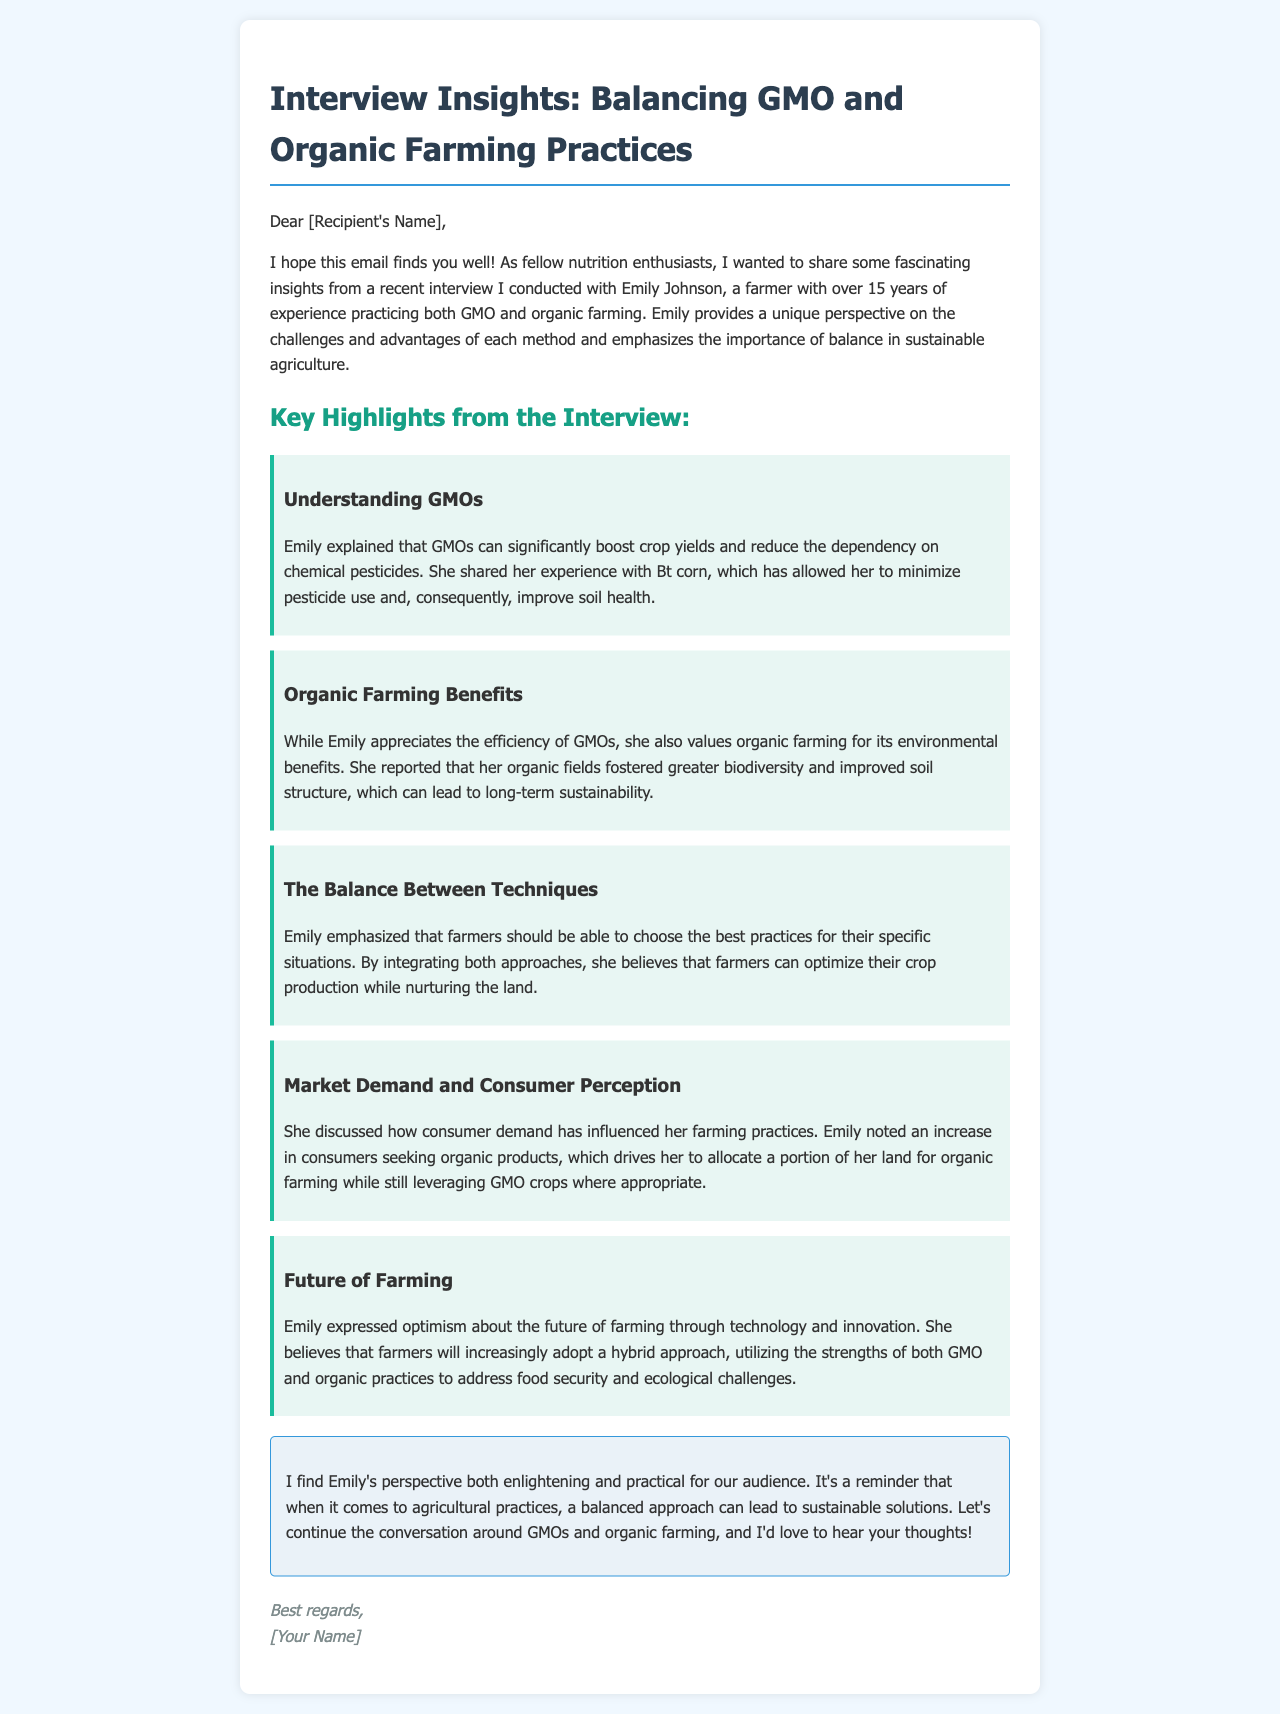What is the name of the farmer interviewed? The farmer interviewed in the document is Emily Johnson, who has over 15 years of experience in farming.
Answer: Emily Johnson How many years of experience does Emily have? The document mentions that Emily has over 15 years of experience practicing both GMO and organic farming.
Answer: 15 years What crop did Emily specifically mention using to minimize pesticide use? Emily mentioned using Bt corn, which helps reduce pesticide use on her farm.
Answer: Bt corn What is one benefit of organic farming according to Emily? Emily highlighted that one benefit of organic farming is fostering greater biodiversity and improved soil structure.
Answer: Biodiversity What future approach does Emily express optimism about? Emily expresses optimism about farmers adopting a hybrid approach, utilizing strengths from both GMO and organic practices.
Answer: Hybrid approach What has influenced Emily's farming practices recently? According to Emily, consumer demand for organic products has influenced her farming practices.
Answer: Consumer demand What is the color scheme of the email's title? The title, "Interview Insights: Balancing GMO and Organic Farming Practices," features a color scheme of blue and dark blue.
Answer: Blue and dark blue What is emphasized as important in sustainable agriculture? Emily emphasizes the importance of balance in sustainable agriculture.
Answer: Balance 